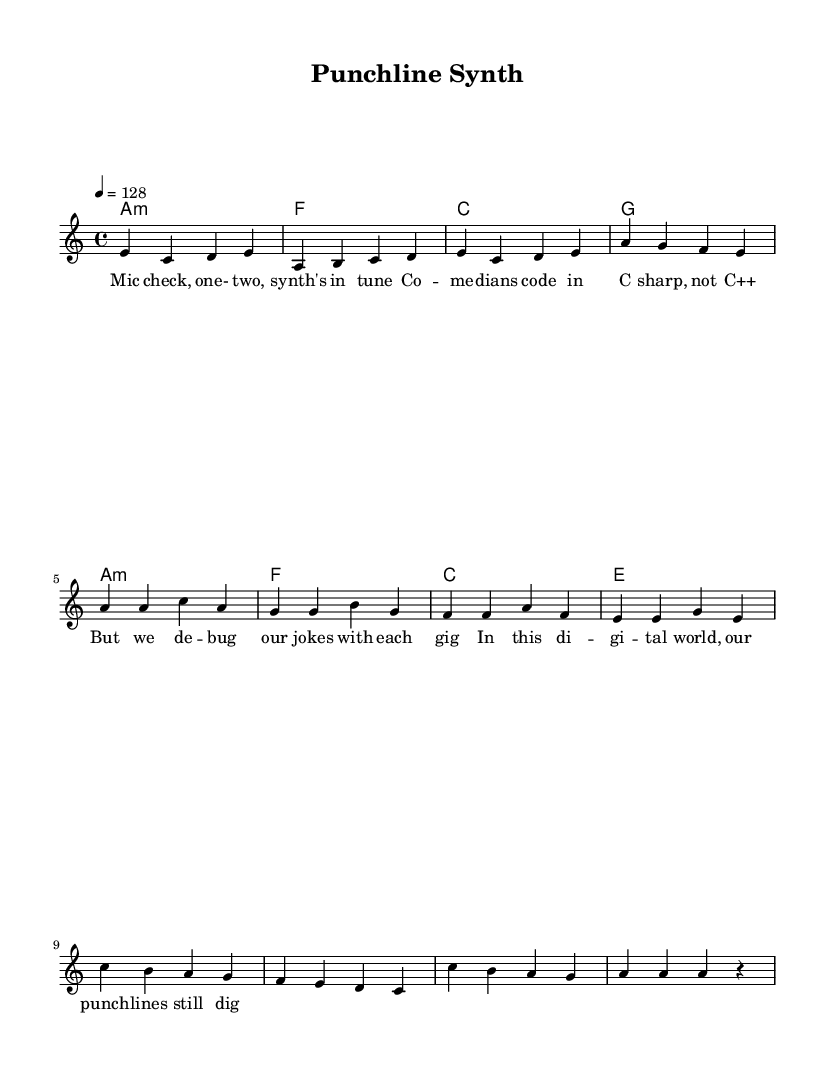What is the key signature of this music? The key signature is A minor, which has no sharps or flats. This can be identified at the beginning of the sheet music where the "a" indicates the note.
Answer: A minor What is the time signature of this music? The time signature is 4/4, which allows four beats per measure and is indicated at the beginning of the piece. This is a standard time signature used in many genres, including electronic music.
Answer: 4/4 What is the tempo of this piece? The tempo is set at 128 beats per minute, as indicated by "4 = 128" in the tempo marking. This tempo is typical for electronic tracks, giving it a danceable feel.
Answer: 128 How many bars are in the verse section? The verse section consists of four measures or bars, as evidenced by the sequences of notes written in the melody part labeled "Verse".
Answer: Four What is the first word of the lyrics? The first word of the lyrics is "Mic", which is noted below the melody in the lyrics section. This sets the comedic tone right from the outset.
Answer: Mic What musical structure is typically found in electronic music? The structure commonly includes verses and choruses, which in this piece is reflected by the distinct sections labeled "Verse" and "Chorus". This alternating structure is typical for engaging listeners.
Answer: Verse and Chorus What does "C sharp" refer to in the lyrics? "C sharp" refers to a musical note, indicating the clever play on words about programming languages, juxtaposing it with comedy in the lyrics. This witty remark highlights the comedic aspect of merging music and technology.
Answer: C sharp 